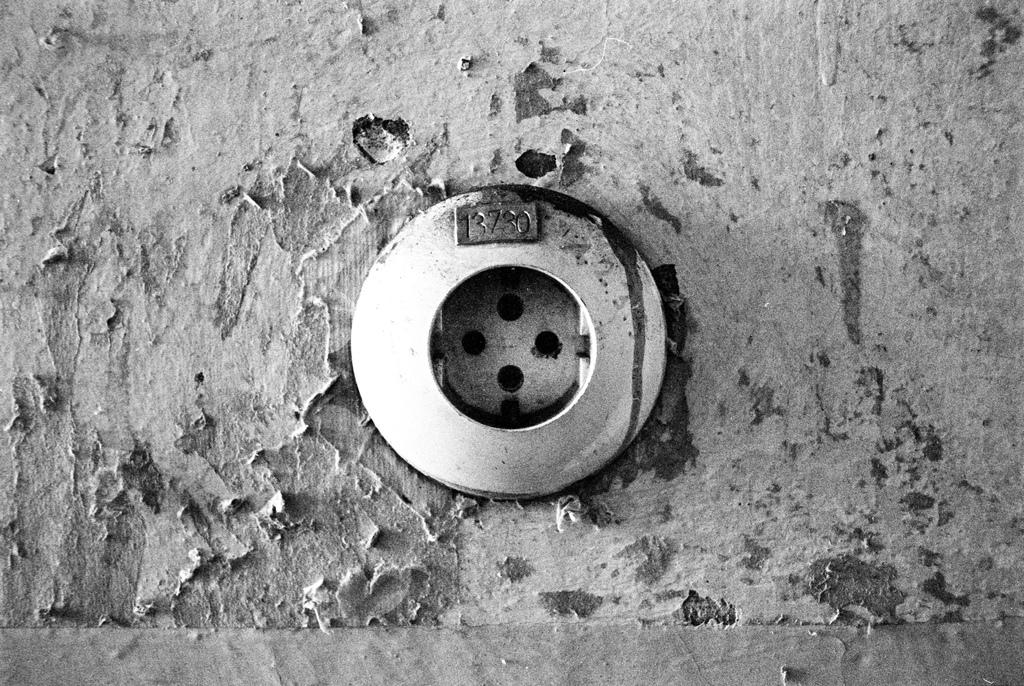What is written on this?
Provide a short and direct response. 13730. What is the identification number on the item?
Your response must be concise. 3730. 